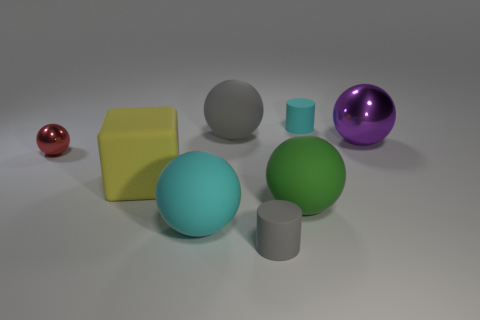How many tiny cyan metal balls are there?
Provide a short and direct response. 0. There is a ball that is both to the right of the large gray rubber ball and in front of the big matte block; what is its color?
Make the answer very short. Green. Are there any tiny gray rubber cylinders behind the tiny gray matte object?
Provide a short and direct response. No. What number of cyan things are in front of the yellow matte object left of the big metallic sphere?
Offer a very short reply. 1. The cube that is the same material as the big cyan thing is what size?
Give a very brief answer. Large. The yellow rubber object has what size?
Provide a short and direct response. Large. Are the green ball and the tiny gray cylinder made of the same material?
Offer a terse response. Yes. How many cylinders are either small red things or small gray shiny things?
Offer a very short reply. 0. There is a small matte object to the left of the small thing behind the red metallic sphere; what is its color?
Your response must be concise. Gray. There is a small red ball to the left of the large rubber ball right of the gray cylinder; what number of balls are to the right of it?
Provide a short and direct response. 4. 